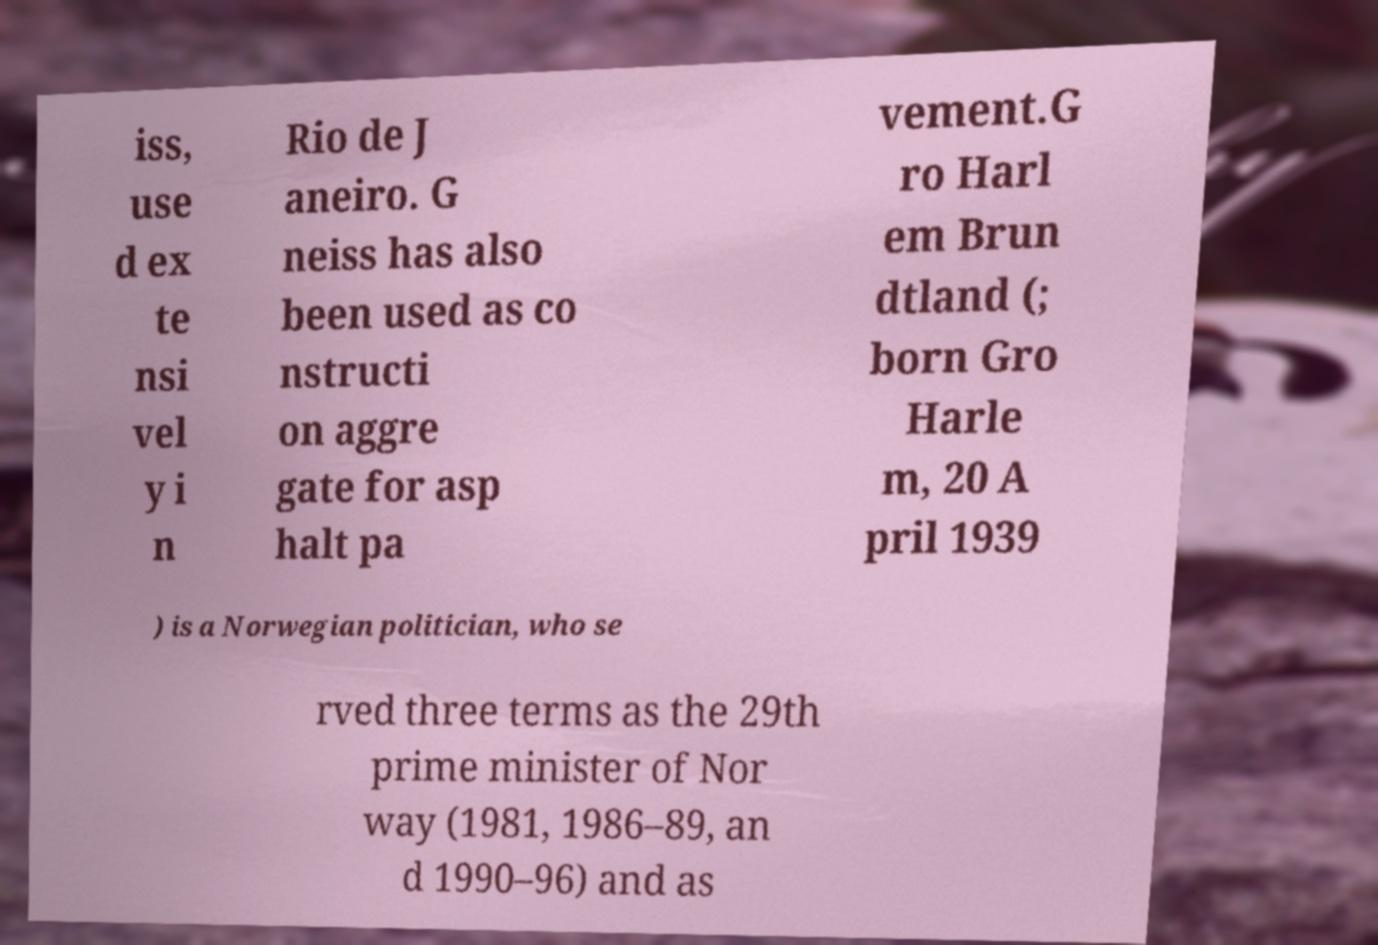Please identify and transcribe the text found in this image. iss, use d ex te nsi vel y i n Rio de J aneiro. G neiss has also been used as co nstructi on aggre gate for asp halt pa vement.G ro Harl em Brun dtland (; born Gro Harle m, 20 A pril 1939 ) is a Norwegian politician, who se rved three terms as the 29th prime minister of Nor way (1981, 1986–89, an d 1990–96) and as 